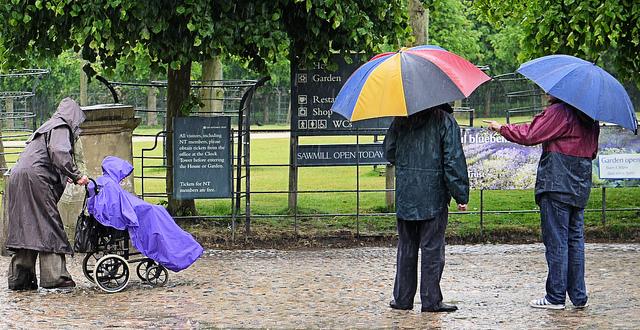Why is she holding an umbrella?
Answer briefly. Rain. Is that a wheelchair?
Answer briefly. Yes. What are these people holding?
Write a very short answer. Umbrellas. Is it raining?
Be succinct. Yes. What color are the man's socks?
Concise answer only. White. 